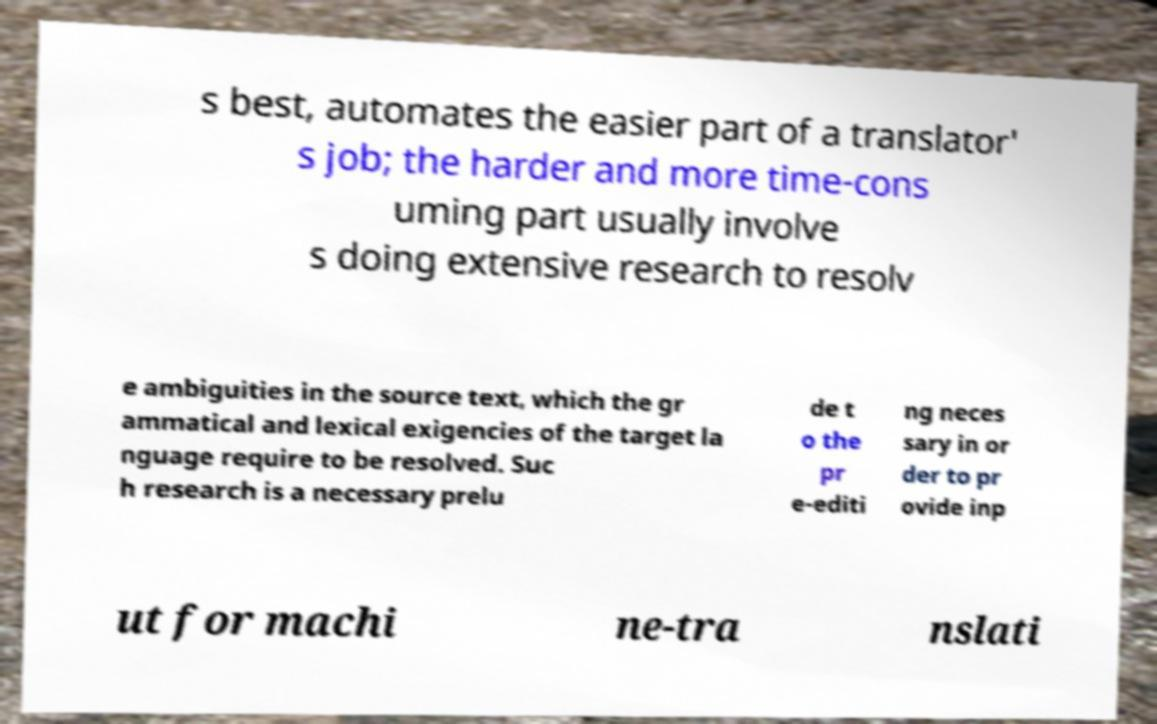What messages or text are displayed in this image? I need them in a readable, typed format. s best, automates the easier part of a translator' s job; the harder and more time-cons uming part usually involve s doing extensive research to resolv e ambiguities in the source text, which the gr ammatical and lexical exigencies of the target la nguage require to be resolved. Suc h research is a necessary prelu de t o the pr e-editi ng neces sary in or der to pr ovide inp ut for machi ne-tra nslati 